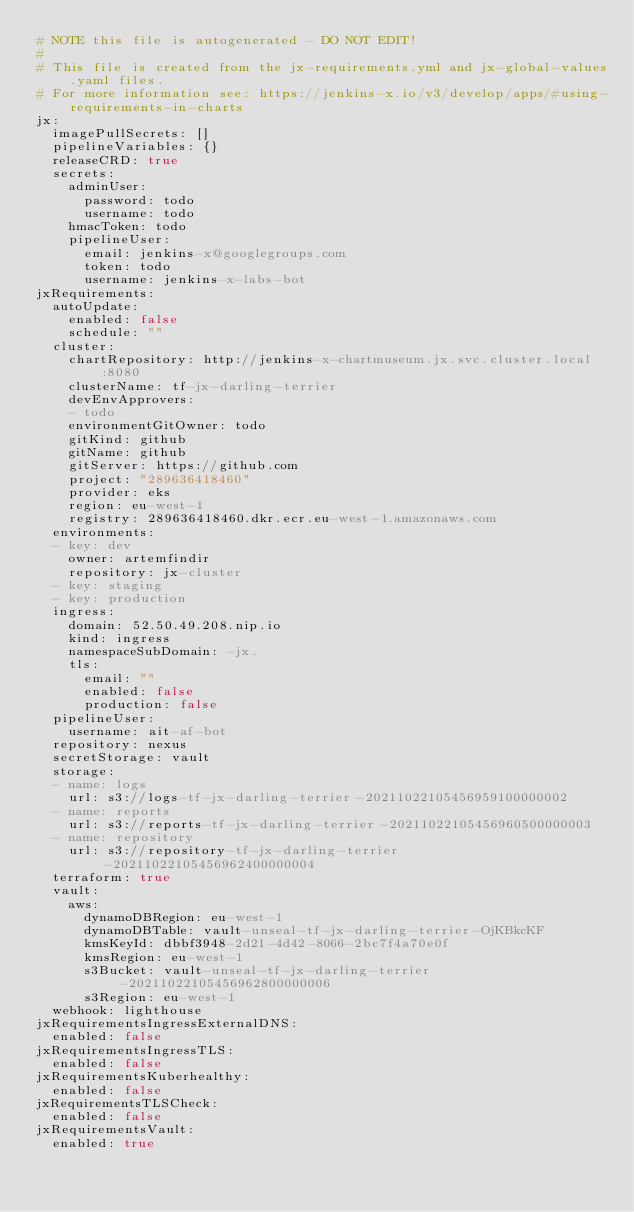Convert code to text. <code><loc_0><loc_0><loc_500><loc_500><_YAML_># NOTE this file is autogenerated - DO NOT EDIT!
#
# This file is created from the jx-requirements.yml and jx-global-values.yaml files.
# For more information see: https://jenkins-x.io/v3/develop/apps/#using-requirements-in-charts
jx:
  imagePullSecrets: []
  pipelineVariables: {}
  releaseCRD: true
  secrets:
    adminUser:
      password: todo
      username: todo
    hmacToken: todo
    pipelineUser:
      email: jenkins-x@googlegroups.com
      token: todo
      username: jenkins-x-labs-bot
jxRequirements:
  autoUpdate:
    enabled: false
    schedule: ""
  cluster:
    chartRepository: http://jenkins-x-chartmuseum.jx.svc.cluster.local:8080
    clusterName: tf-jx-darling-terrier
    devEnvApprovers:
    - todo
    environmentGitOwner: todo
    gitKind: github
    gitName: github
    gitServer: https://github.com
    project: "289636418460"
    provider: eks
    region: eu-west-1
    registry: 289636418460.dkr.ecr.eu-west-1.amazonaws.com
  environments:
  - key: dev
    owner: artemfindir
    repository: jx-cluster
  - key: staging
  - key: production
  ingress:
    domain: 52.50.49.208.nip.io
    kind: ingress
    namespaceSubDomain: -jx.
    tls:
      email: ""
      enabled: false
      production: false
  pipelineUser:
    username: ait-af-bot
  repository: nexus
  secretStorage: vault
  storage:
  - name: logs
    url: s3://logs-tf-jx-darling-terrier-20211022105456959100000002
  - name: reports
    url: s3://reports-tf-jx-darling-terrier-20211022105456960500000003
  - name: repository
    url: s3://repository-tf-jx-darling-terrier-20211022105456962400000004
  terraform: true
  vault:
    aws:
      dynamoDBRegion: eu-west-1
      dynamoDBTable: vault-unseal-tf-jx-darling-terrier-OjKBkcKF
      kmsKeyId: dbbf3948-2d21-4d42-8066-2bc7f4a70e0f
      kmsRegion: eu-west-1
      s3Bucket: vault-unseal-tf-jx-darling-terrier-20211022105456962800000006
      s3Region: eu-west-1
  webhook: lighthouse
jxRequirementsIngressExternalDNS:
  enabled: false
jxRequirementsIngressTLS:
  enabled: false
jxRequirementsKuberhealthy:
  enabled: false
jxRequirementsTLSCheck:
  enabled: false
jxRequirementsVault:
  enabled: true
</code> 